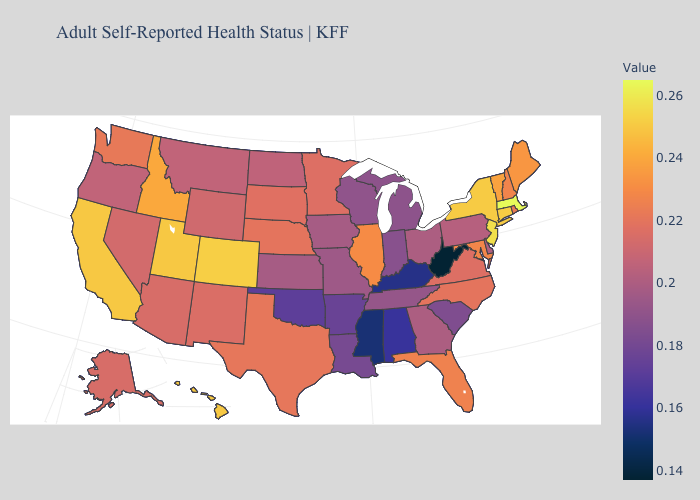Which states have the highest value in the USA?
Be succinct. Massachusetts. Does West Virginia have the lowest value in the USA?
Concise answer only. Yes. Does New York have a lower value than Massachusetts?
Give a very brief answer. Yes. Does Massachusetts have the highest value in the USA?
Answer briefly. Yes. 